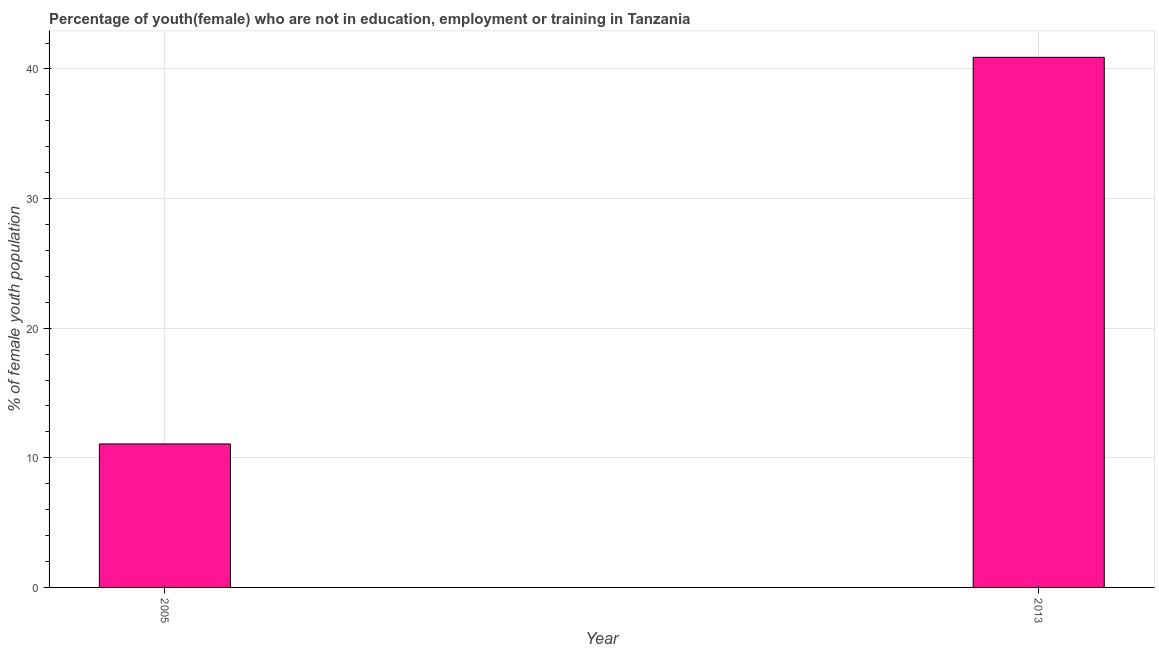Does the graph contain any zero values?
Keep it short and to the point. No. What is the title of the graph?
Ensure brevity in your answer.  Percentage of youth(female) who are not in education, employment or training in Tanzania. What is the label or title of the Y-axis?
Provide a succinct answer. % of female youth population. What is the unemployed female youth population in 2005?
Make the answer very short. 11.07. Across all years, what is the maximum unemployed female youth population?
Your answer should be very brief. 40.9. Across all years, what is the minimum unemployed female youth population?
Provide a succinct answer. 11.07. In which year was the unemployed female youth population maximum?
Make the answer very short. 2013. In which year was the unemployed female youth population minimum?
Your answer should be compact. 2005. What is the sum of the unemployed female youth population?
Your answer should be very brief. 51.97. What is the difference between the unemployed female youth population in 2005 and 2013?
Offer a very short reply. -29.83. What is the average unemployed female youth population per year?
Give a very brief answer. 25.98. What is the median unemployed female youth population?
Give a very brief answer. 25.99. Do a majority of the years between 2013 and 2005 (inclusive) have unemployed female youth population greater than 6 %?
Offer a very short reply. No. What is the ratio of the unemployed female youth population in 2005 to that in 2013?
Make the answer very short. 0.27. Is the unemployed female youth population in 2005 less than that in 2013?
Your answer should be very brief. Yes. In how many years, is the unemployed female youth population greater than the average unemployed female youth population taken over all years?
Provide a succinct answer. 1. Are all the bars in the graph horizontal?
Offer a terse response. No. What is the difference between two consecutive major ticks on the Y-axis?
Your response must be concise. 10. What is the % of female youth population in 2005?
Offer a very short reply. 11.07. What is the % of female youth population in 2013?
Provide a short and direct response. 40.9. What is the difference between the % of female youth population in 2005 and 2013?
Your answer should be compact. -29.83. What is the ratio of the % of female youth population in 2005 to that in 2013?
Offer a very short reply. 0.27. 